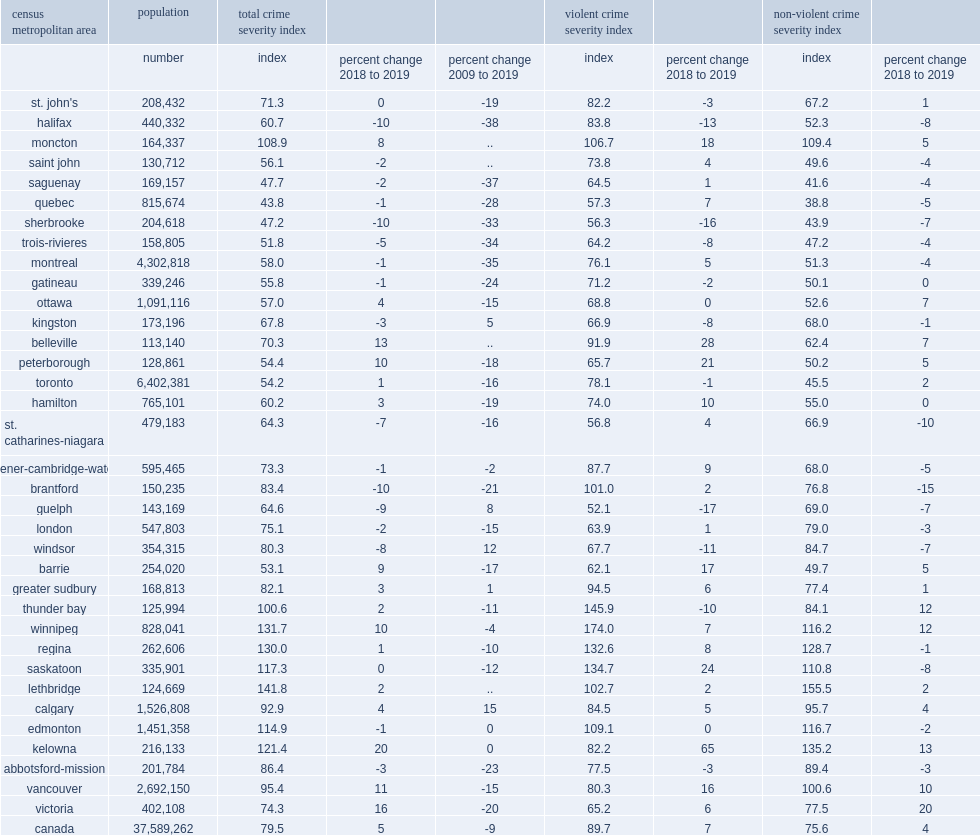What was the largest violent crime severity index percent from 2018 to 2019 increases reported in kelowna? 65.0. What was the largest violent crime severity index percent from 2018 to 2019 increases reported in belleville? 28.0. What was the largest violent crime severity index percent from 2018 to 2019 increases reported in saskatoon? 24.0. What was the largest violent crime severity index percent from 2018 to 2019 increases reported in peterborough? 21.0. What was the percent of breaking and entering also a driver in many of the cmas with the largest decreases in brantford? -15.0. What was the percent of breaking and entering also a driver in many of the cmas with the largest decreases in st. catharines-niagara? -10.0. What was the percent of breaking and entering also a driver in many of the cmas with the largest decreases in saskatoon? -8.0. What was the percent of breaking and entering also a driver in many of the cmas with the largest decreases in halifax? -8.0. 